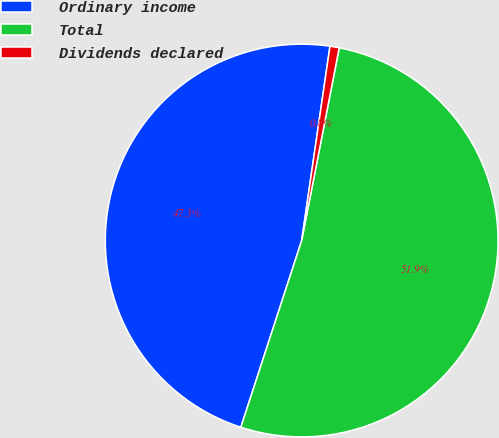<chart> <loc_0><loc_0><loc_500><loc_500><pie_chart><fcel>Ordinary income<fcel>Total<fcel>Dividends declared<nl><fcel>47.29%<fcel>51.95%<fcel>0.76%<nl></chart> 